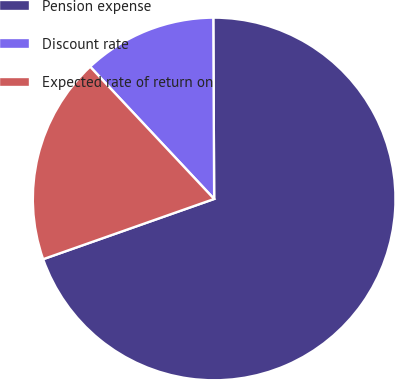Convert chart to OTSL. <chart><loc_0><loc_0><loc_500><loc_500><pie_chart><fcel>Pension expense<fcel>Discount rate<fcel>Expected rate of return on<nl><fcel>69.68%<fcel>11.91%<fcel>18.4%<nl></chart> 